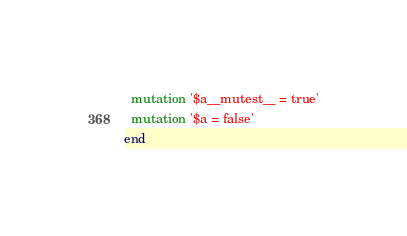<code> <loc_0><loc_0><loc_500><loc_500><_Ruby_>  mutation '$a__mutest__ = true'
  mutation '$a = false'
end
</code> 